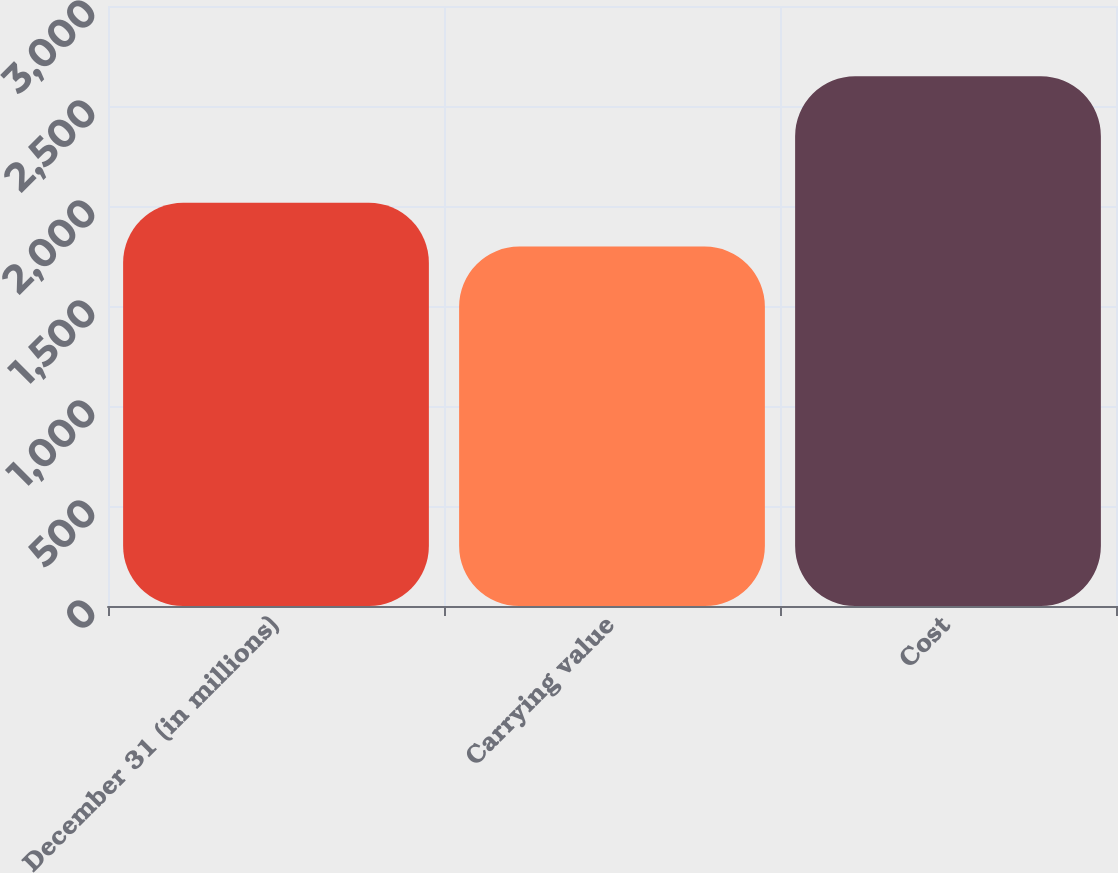<chart> <loc_0><loc_0><loc_500><loc_500><bar_chart><fcel>December 31 (in millions)<fcel>Carrying value<fcel>Cost<nl><fcel>2016<fcel>1797<fcel>2649<nl></chart> 